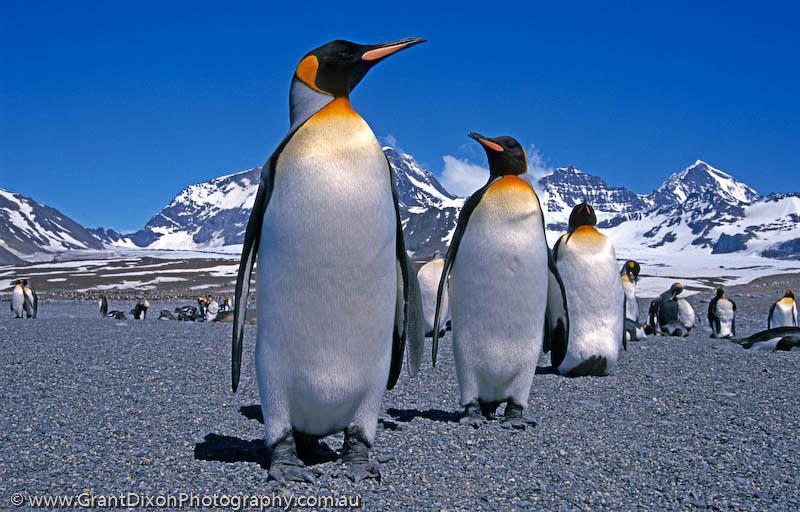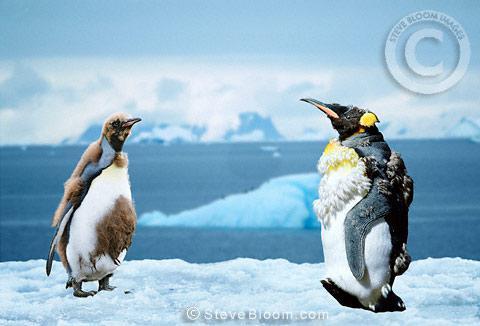The first image is the image on the left, the second image is the image on the right. Given the left and right images, does the statement "An image shows two foreground penguins with furry patches." hold true? Answer yes or no. Yes. The first image is the image on the left, the second image is the image on the right. Considering the images on both sides, is "At least one image shows only two penguins." valid? Answer yes or no. Yes. The first image is the image on the left, the second image is the image on the right. Considering the images on both sides, is "One of the pictures has only two penguins." valid? Answer yes or no. Yes. The first image is the image on the left, the second image is the image on the right. Examine the images to the left and right. Is the description "There is one image with two penguins standing on ice." accurate? Answer yes or no. Yes. 